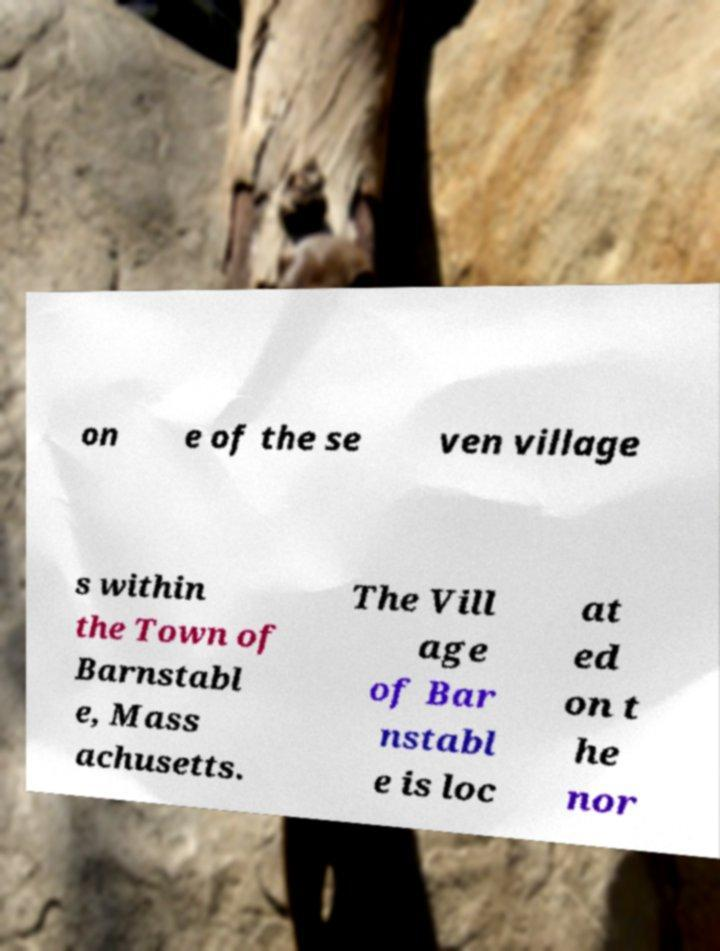I need the written content from this picture converted into text. Can you do that? on e of the se ven village s within the Town of Barnstabl e, Mass achusetts. The Vill age of Bar nstabl e is loc at ed on t he nor 